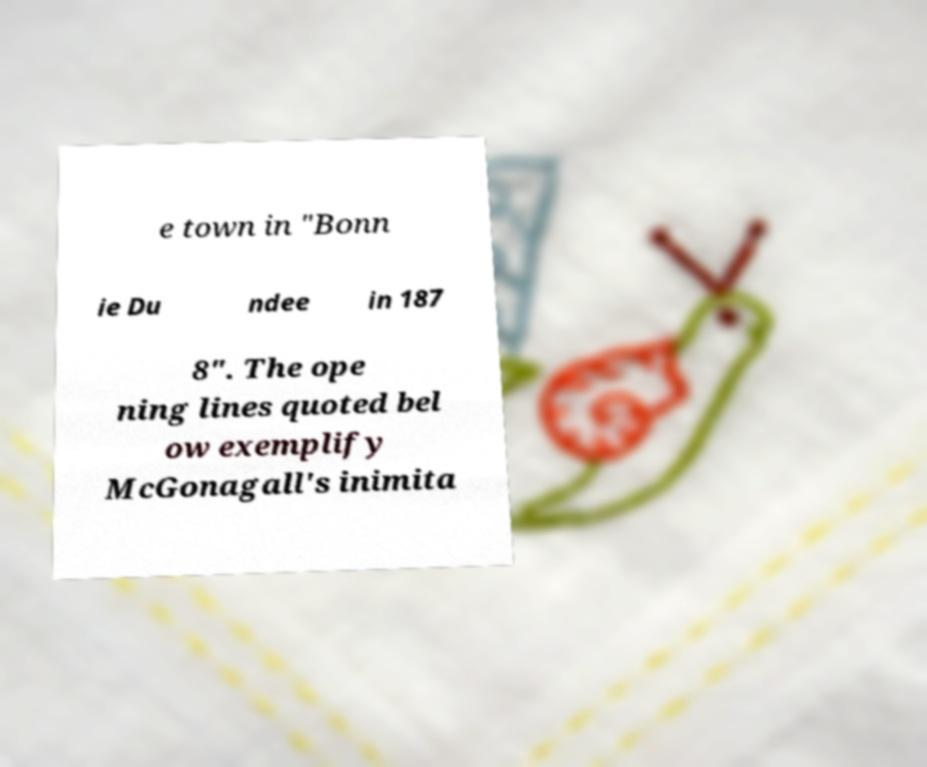For documentation purposes, I need the text within this image transcribed. Could you provide that? e town in "Bonn ie Du ndee in 187 8". The ope ning lines quoted bel ow exemplify McGonagall's inimita 